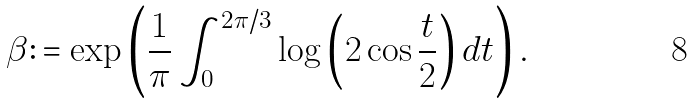<formula> <loc_0><loc_0><loc_500><loc_500>\beta \colon = \exp \left ( \frac { 1 } { \pi } \int _ { 0 } ^ { 2 \pi / 3 } \log \left ( 2 \cos \frac { t } { 2 } \right ) d t \right ) .</formula> 